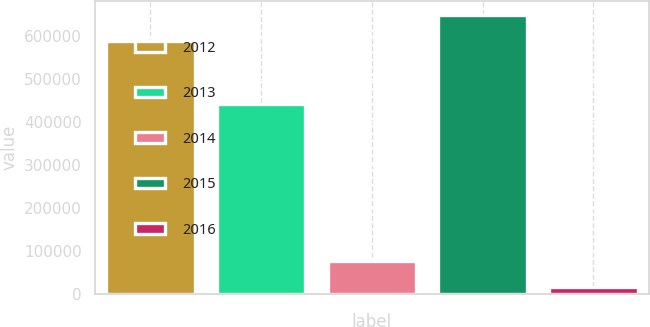<chart> <loc_0><loc_0><loc_500><loc_500><bar_chart><fcel>2012<fcel>2013<fcel>2014<fcel>2015<fcel>2016<nl><fcel>588222<fcel>443370<fcel>77283.3<fcel>649244<fcel>16261<nl></chart> 